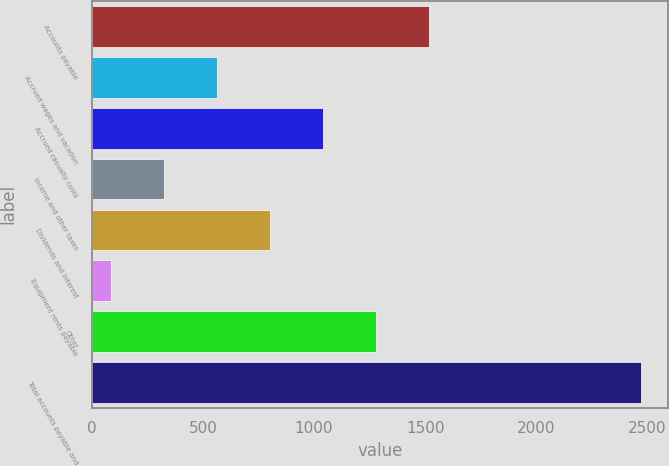Convert chart. <chart><loc_0><loc_0><loc_500><loc_500><bar_chart><fcel>Accounts payable<fcel>Accrued wages and vacation<fcel>Accrued casualty costs<fcel>Income and other taxes<fcel>Dividends and interest<fcel>Equipment rents payable<fcel>Other<fcel>Total accounts payable and<nl><fcel>1517.6<fcel>565.2<fcel>1041.4<fcel>327.1<fcel>803.3<fcel>89<fcel>1279.5<fcel>2470<nl></chart> 